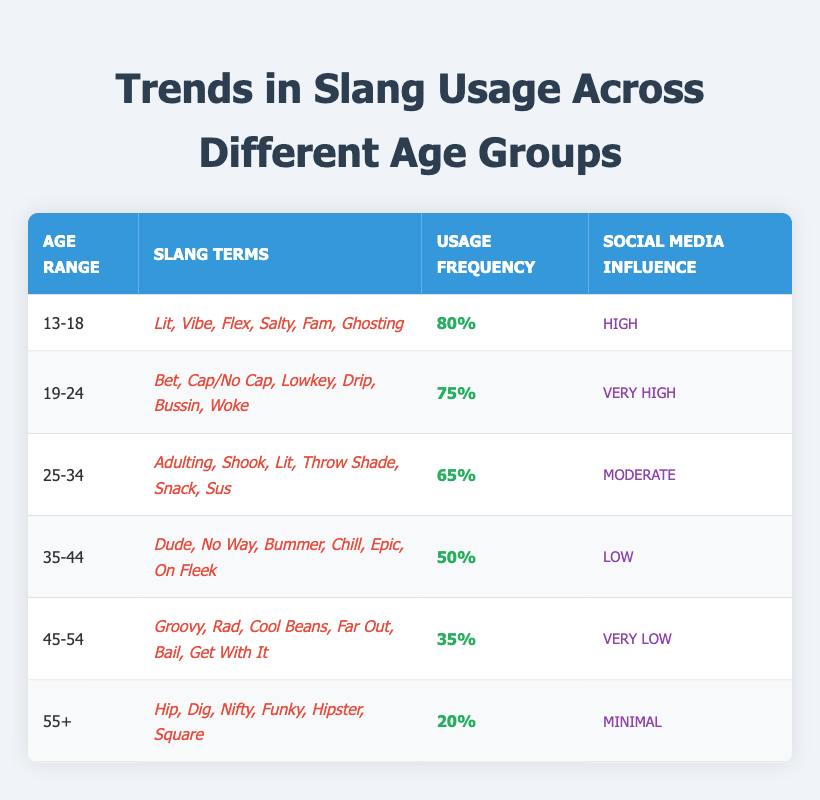What is the slang term with the highest usage frequency among the age group 13-18? The age group 13-18 has a usage frequency of 80%, and the slang terms mentioned are Lit, Vibe, Flex, Salty, Fam, and Ghosting. The term with the highest usage frequency is therefore 80%.
Answer: 80% What slang terms are used by the age group 25-34? The age group 25-34 uses the slang terms Adulting, Shook, Lit, Throw Shade, Snack, and Sus. These terms are listed under the slang terms column for this age group.
Answer: Adulting, Shook, Lit, Throw Shade, Snack, Sus Is the social media influence on slang usage higher for the age group 19-24 compared to the age group 35-44? The social media influence for the age group 19-24 is "Very High" whereas the influence for the age group 35-44 is "Low". Since "Very High" is indeed higher than "Low", the statement is true.
Answer: Yes What is the average usage frequency for the age groups 45-54 and 55+? To find the average, we sum the usage frequencies: 35% (for 45-54) + 20% (for 55+) = 55%. There are 2 age groups, so we divide by 2: 55%/2 = 27.5%. Therefore, the average is 27.5%.
Answer: 27.5% Do any age groups use the slang term "Lit"? The slang term "Lit" is used by both the age groups 13-18 and 25-34, as confirmed by their lists of slang terms. Thus, the answer is yes.
Answer: Yes Which age group has the least usage frequency of slang? Referring to the table, the age group 55+ has the lowest usage frequency at 20%. This is the least among all groups listed.
Answer: 55+ How many slang terms are used by the age group 45-54? The age group 45-54 has six slang terms listed: Groovy, Rad, Cool Beans, Far Out, Bail, and Get With It. Therefore, the total count of terms is 6.
Answer: 6 What is the difference in usage frequency between the age groups 13-18 and 35-44? The usage frequency for age group 13-18 is 80% and for age group 35-44 is 50%. The difference is calculated as 80% - 50% = 30%. Thus, the final answer is 30%.
Answer: 30% Which age groups have a "Moderate" social media influence? The age group 25-34 is the only group with a "Moderate" social media influence as listed in the table. Therefore, only one age group fits this description.
Answer: 25-34 